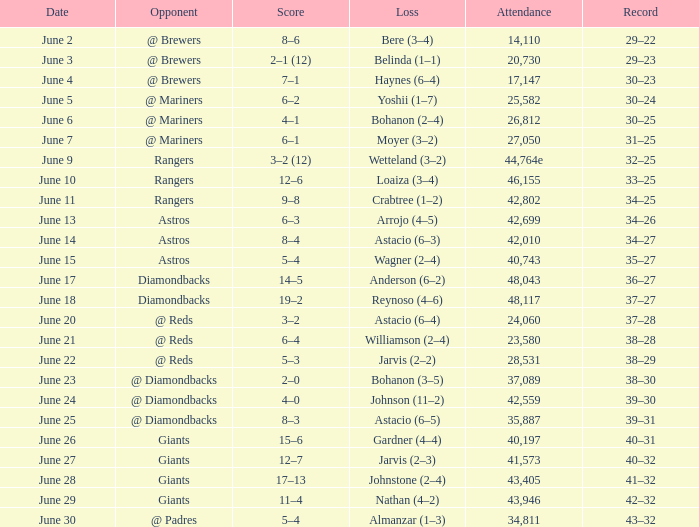Who's the opponent for June 13? Astros. 